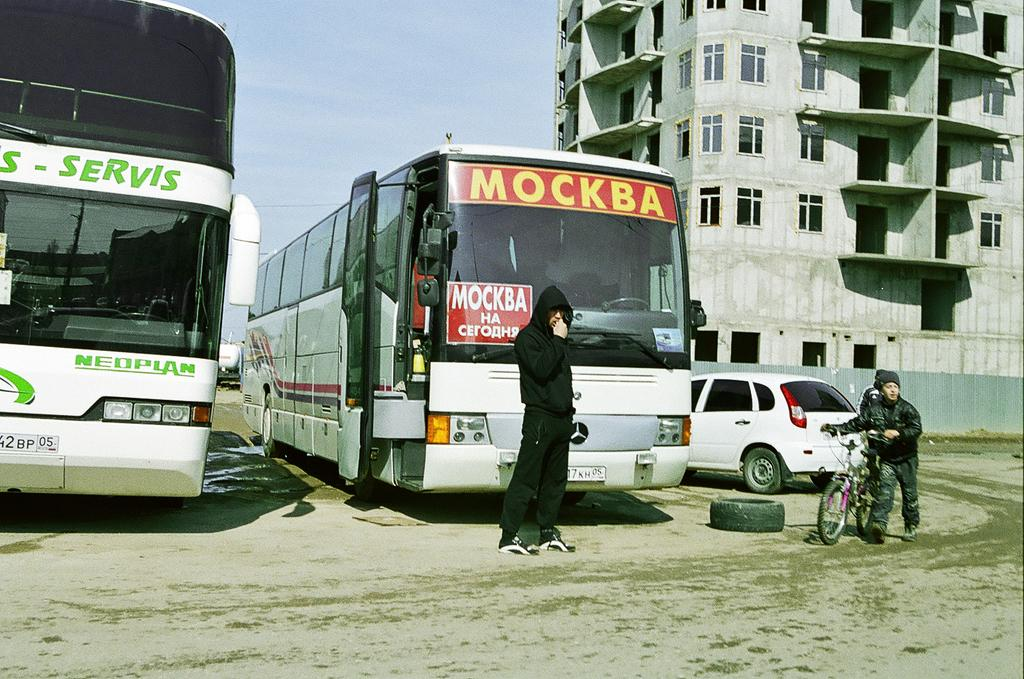<image>
Describe the image concisely. A city bus that says  MOCKBA across the front. 